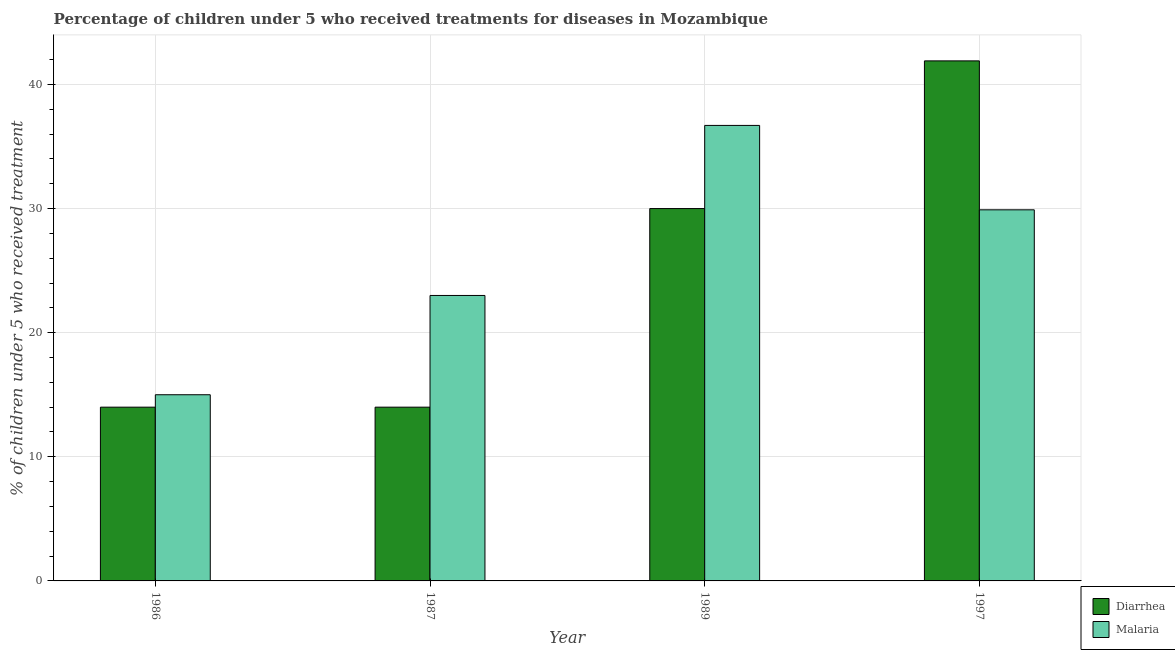How many different coloured bars are there?
Keep it short and to the point. 2. Are the number of bars per tick equal to the number of legend labels?
Ensure brevity in your answer.  Yes. How many bars are there on the 3rd tick from the right?
Ensure brevity in your answer.  2. What is the label of the 1st group of bars from the left?
Provide a short and direct response. 1986. In how many cases, is the number of bars for a given year not equal to the number of legend labels?
Offer a terse response. 0. What is the percentage of children who received treatment for diarrhoea in 1989?
Your answer should be compact. 30. Across all years, what is the maximum percentage of children who received treatment for malaria?
Give a very brief answer. 36.7. Across all years, what is the minimum percentage of children who received treatment for malaria?
Ensure brevity in your answer.  15. In which year was the percentage of children who received treatment for diarrhoea minimum?
Make the answer very short. 1986. What is the total percentage of children who received treatment for diarrhoea in the graph?
Give a very brief answer. 99.9. What is the difference between the percentage of children who received treatment for malaria in 1986 and the percentage of children who received treatment for diarrhoea in 1989?
Offer a very short reply. -21.7. What is the average percentage of children who received treatment for diarrhoea per year?
Give a very brief answer. 24.98. What is the ratio of the percentage of children who received treatment for malaria in 1986 to that in 1987?
Your response must be concise. 0.65. Is the difference between the percentage of children who received treatment for diarrhoea in 1986 and 1989 greater than the difference between the percentage of children who received treatment for malaria in 1986 and 1989?
Keep it short and to the point. No. What is the difference between the highest and the second highest percentage of children who received treatment for malaria?
Offer a terse response. 6.8. What is the difference between the highest and the lowest percentage of children who received treatment for malaria?
Ensure brevity in your answer.  21.7. What does the 2nd bar from the left in 1989 represents?
Give a very brief answer. Malaria. What does the 1st bar from the right in 1987 represents?
Provide a short and direct response. Malaria. How many bars are there?
Offer a terse response. 8. What is the difference between two consecutive major ticks on the Y-axis?
Your answer should be compact. 10. Does the graph contain any zero values?
Your answer should be compact. No. Where does the legend appear in the graph?
Ensure brevity in your answer.  Bottom right. How many legend labels are there?
Provide a short and direct response. 2. What is the title of the graph?
Make the answer very short. Percentage of children under 5 who received treatments for diseases in Mozambique. Does "Female labourers" appear as one of the legend labels in the graph?
Provide a succinct answer. No. What is the label or title of the X-axis?
Offer a terse response. Year. What is the label or title of the Y-axis?
Provide a short and direct response. % of children under 5 who received treatment. What is the % of children under 5 who received treatment of Malaria in 1989?
Your answer should be very brief. 36.7. What is the % of children under 5 who received treatment of Diarrhea in 1997?
Your answer should be compact. 41.9. What is the % of children under 5 who received treatment in Malaria in 1997?
Provide a short and direct response. 29.9. Across all years, what is the maximum % of children under 5 who received treatment of Diarrhea?
Offer a terse response. 41.9. Across all years, what is the maximum % of children under 5 who received treatment of Malaria?
Give a very brief answer. 36.7. Across all years, what is the minimum % of children under 5 who received treatment in Diarrhea?
Your answer should be very brief. 14. What is the total % of children under 5 who received treatment of Diarrhea in the graph?
Your answer should be very brief. 99.9. What is the total % of children under 5 who received treatment of Malaria in the graph?
Give a very brief answer. 104.6. What is the difference between the % of children under 5 who received treatment in Diarrhea in 1986 and that in 1987?
Ensure brevity in your answer.  0. What is the difference between the % of children under 5 who received treatment of Malaria in 1986 and that in 1989?
Offer a terse response. -21.7. What is the difference between the % of children under 5 who received treatment of Diarrhea in 1986 and that in 1997?
Offer a terse response. -27.9. What is the difference between the % of children under 5 who received treatment of Malaria in 1986 and that in 1997?
Give a very brief answer. -14.9. What is the difference between the % of children under 5 who received treatment in Malaria in 1987 and that in 1989?
Your response must be concise. -13.7. What is the difference between the % of children under 5 who received treatment of Diarrhea in 1987 and that in 1997?
Give a very brief answer. -27.9. What is the difference between the % of children under 5 who received treatment in Diarrhea in 1989 and that in 1997?
Give a very brief answer. -11.9. What is the difference between the % of children under 5 who received treatment in Diarrhea in 1986 and the % of children under 5 who received treatment in Malaria in 1989?
Offer a very short reply. -22.7. What is the difference between the % of children under 5 who received treatment of Diarrhea in 1986 and the % of children under 5 who received treatment of Malaria in 1997?
Your answer should be compact. -15.9. What is the difference between the % of children under 5 who received treatment of Diarrhea in 1987 and the % of children under 5 who received treatment of Malaria in 1989?
Your response must be concise. -22.7. What is the difference between the % of children under 5 who received treatment of Diarrhea in 1987 and the % of children under 5 who received treatment of Malaria in 1997?
Keep it short and to the point. -15.9. What is the difference between the % of children under 5 who received treatment of Diarrhea in 1989 and the % of children under 5 who received treatment of Malaria in 1997?
Your response must be concise. 0.1. What is the average % of children under 5 who received treatment in Diarrhea per year?
Offer a terse response. 24.98. What is the average % of children under 5 who received treatment of Malaria per year?
Provide a short and direct response. 26.15. In the year 1989, what is the difference between the % of children under 5 who received treatment of Diarrhea and % of children under 5 who received treatment of Malaria?
Keep it short and to the point. -6.7. In the year 1997, what is the difference between the % of children under 5 who received treatment in Diarrhea and % of children under 5 who received treatment in Malaria?
Provide a succinct answer. 12. What is the ratio of the % of children under 5 who received treatment of Malaria in 1986 to that in 1987?
Give a very brief answer. 0.65. What is the ratio of the % of children under 5 who received treatment in Diarrhea in 1986 to that in 1989?
Your answer should be compact. 0.47. What is the ratio of the % of children under 5 who received treatment of Malaria in 1986 to that in 1989?
Your answer should be compact. 0.41. What is the ratio of the % of children under 5 who received treatment in Diarrhea in 1986 to that in 1997?
Your answer should be compact. 0.33. What is the ratio of the % of children under 5 who received treatment in Malaria in 1986 to that in 1997?
Ensure brevity in your answer.  0.5. What is the ratio of the % of children under 5 who received treatment in Diarrhea in 1987 to that in 1989?
Give a very brief answer. 0.47. What is the ratio of the % of children under 5 who received treatment of Malaria in 1987 to that in 1989?
Your answer should be compact. 0.63. What is the ratio of the % of children under 5 who received treatment in Diarrhea in 1987 to that in 1997?
Keep it short and to the point. 0.33. What is the ratio of the % of children under 5 who received treatment of Malaria in 1987 to that in 1997?
Offer a terse response. 0.77. What is the ratio of the % of children under 5 who received treatment in Diarrhea in 1989 to that in 1997?
Offer a very short reply. 0.72. What is the ratio of the % of children under 5 who received treatment in Malaria in 1989 to that in 1997?
Your answer should be compact. 1.23. What is the difference between the highest and the second highest % of children under 5 who received treatment in Diarrhea?
Ensure brevity in your answer.  11.9. What is the difference between the highest and the lowest % of children under 5 who received treatment of Diarrhea?
Give a very brief answer. 27.9. What is the difference between the highest and the lowest % of children under 5 who received treatment of Malaria?
Offer a terse response. 21.7. 